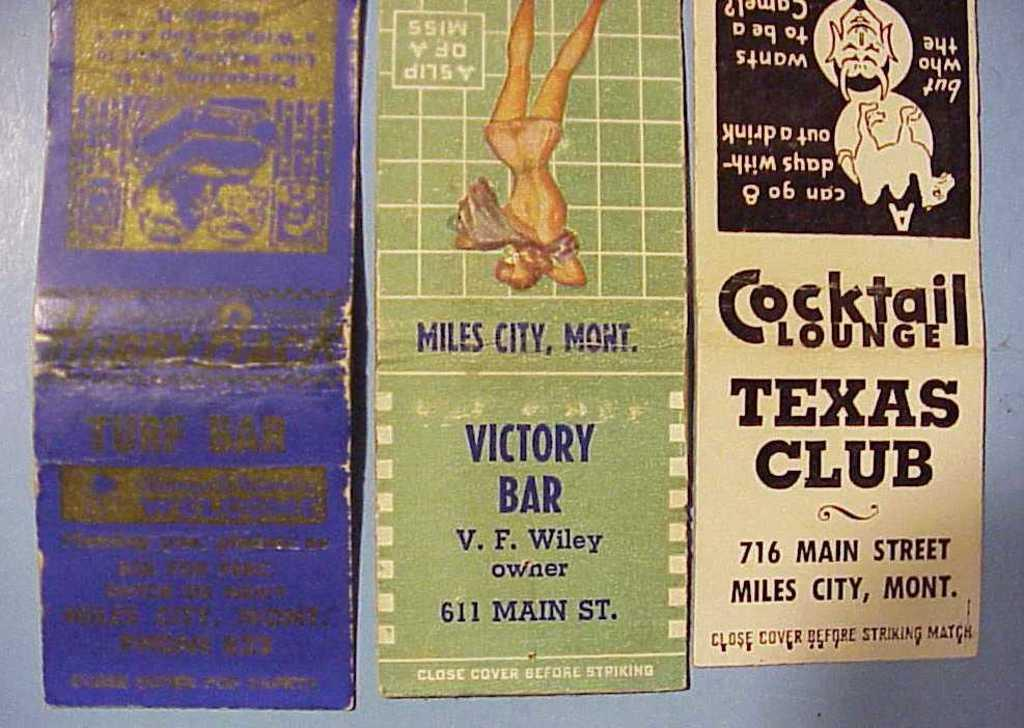<image>
Give a short and clear explanation of the subsequent image. Three pamphlets with one advertising the Cocktail Lounge Texas Club in Miles City, Mont. 